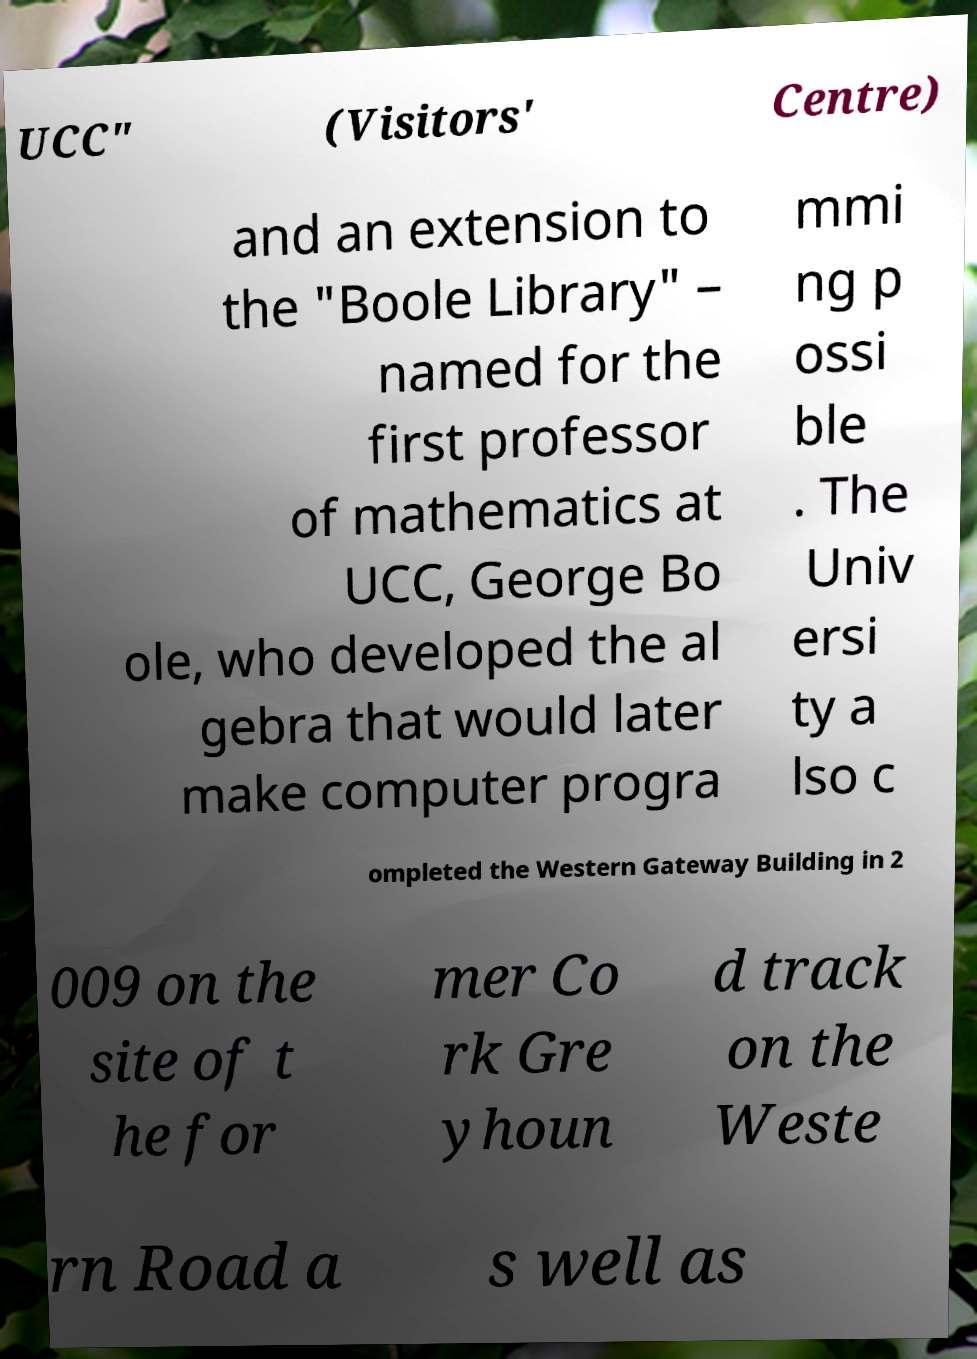For documentation purposes, I need the text within this image transcribed. Could you provide that? UCC" (Visitors' Centre) and an extension to the "Boole Library" – named for the first professor of mathematics at UCC, George Bo ole, who developed the al gebra that would later make computer progra mmi ng p ossi ble . The Univ ersi ty a lso c ompleted the Western Gateway Building in 2 009 on the site of t he for mer Co rk Gre yhoun d track on the Weste rn Road a s well as 